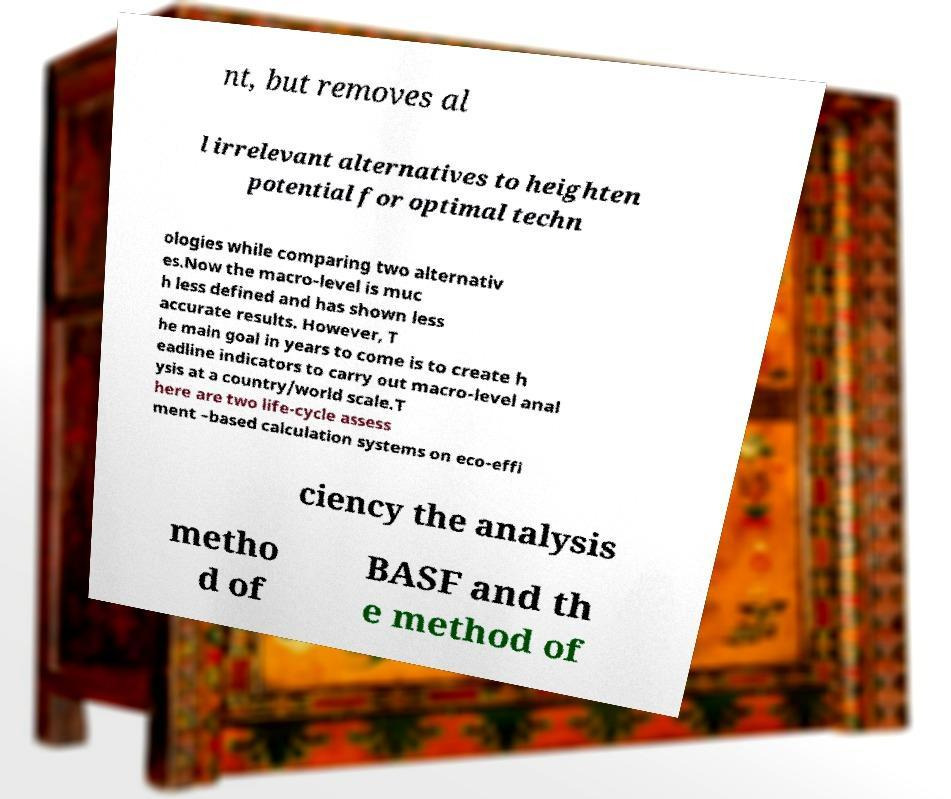For documentation purposes, I need the text within this image transcribed. Could you provide that? nt, but removes al l irrelevant alternatives to heighten potential for optimal techn ologies while comparing two alternativ es.Now the macro-level is muc h less defined and has shown less accurate results. However, T he main goal in years to come is to create h eadline indicators to carry out macro-level anal ysis at a country/world scale.T here are two life-cycle assess ment –based calculation systems on eco-effi ciency the analysis metho d of BASF and th e method of 